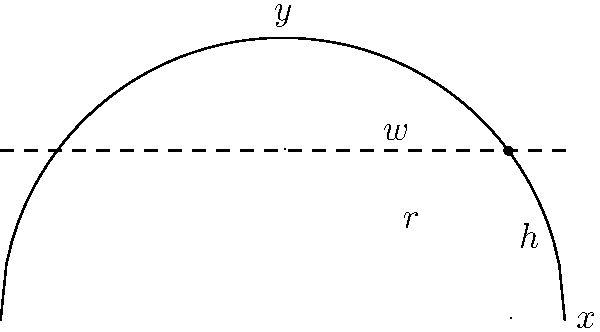As an imam studying the visibility of the crescent moon, you encounter a calculus problem. The moon's illuminated edge can be modeled as a semicircle with radius $r=1$. A horizontal line at height $h=0.6$ intersects the semicircle, creating a crescent shape. Find the width $w$ of the crescent at this height using calculus methods. Express your answer in terms of $\pi$. Let's approach this step-by-step:

1) The semicircle is described by the equation $x^2 + y^2 = 1$ for $y \geq 0$.

2) At the point of intersection, $y = h = 0.6$.

3) To find the x-coordinate of the intersection point, we substitute $y = 0.6$ into the circle equation:

   $x^2 + 0.6^2 = 1$
   $x^2 = 1 - 0.36 = 0.64$
   $x = \sqrt{0.64} = 0.8$

4) The width of the crescent is twice this x-value: $w = 2(0.8) = 1.6$

5) To express this in terms of $\pi$, we need to find the angle $\theta$ corresponding to this point:

   $\cos \theta = 0.8$
   $\theta = \arccos(0.8)$

6) The width can be expressed as $w = 2r\sin(\theta)$, where $r=1$

7) Therefore, $w = 2\sin(\arccos(0.8))$

8) This can be simplified to $w = 2\sqrt{1-0.8^2} = 2(0.6) = 1.2$

9) To express in terms of $\pi$, we can use the fact that $1.2 = \frac{1.2\pi}{\pi}$

Therefore, the width can be expressed as $\frac{1.2\pi}{\pi}$ or $\frac{6\pi}{5\pi}$.
Answer: $\frac{6\pi}{5\pi}$ 